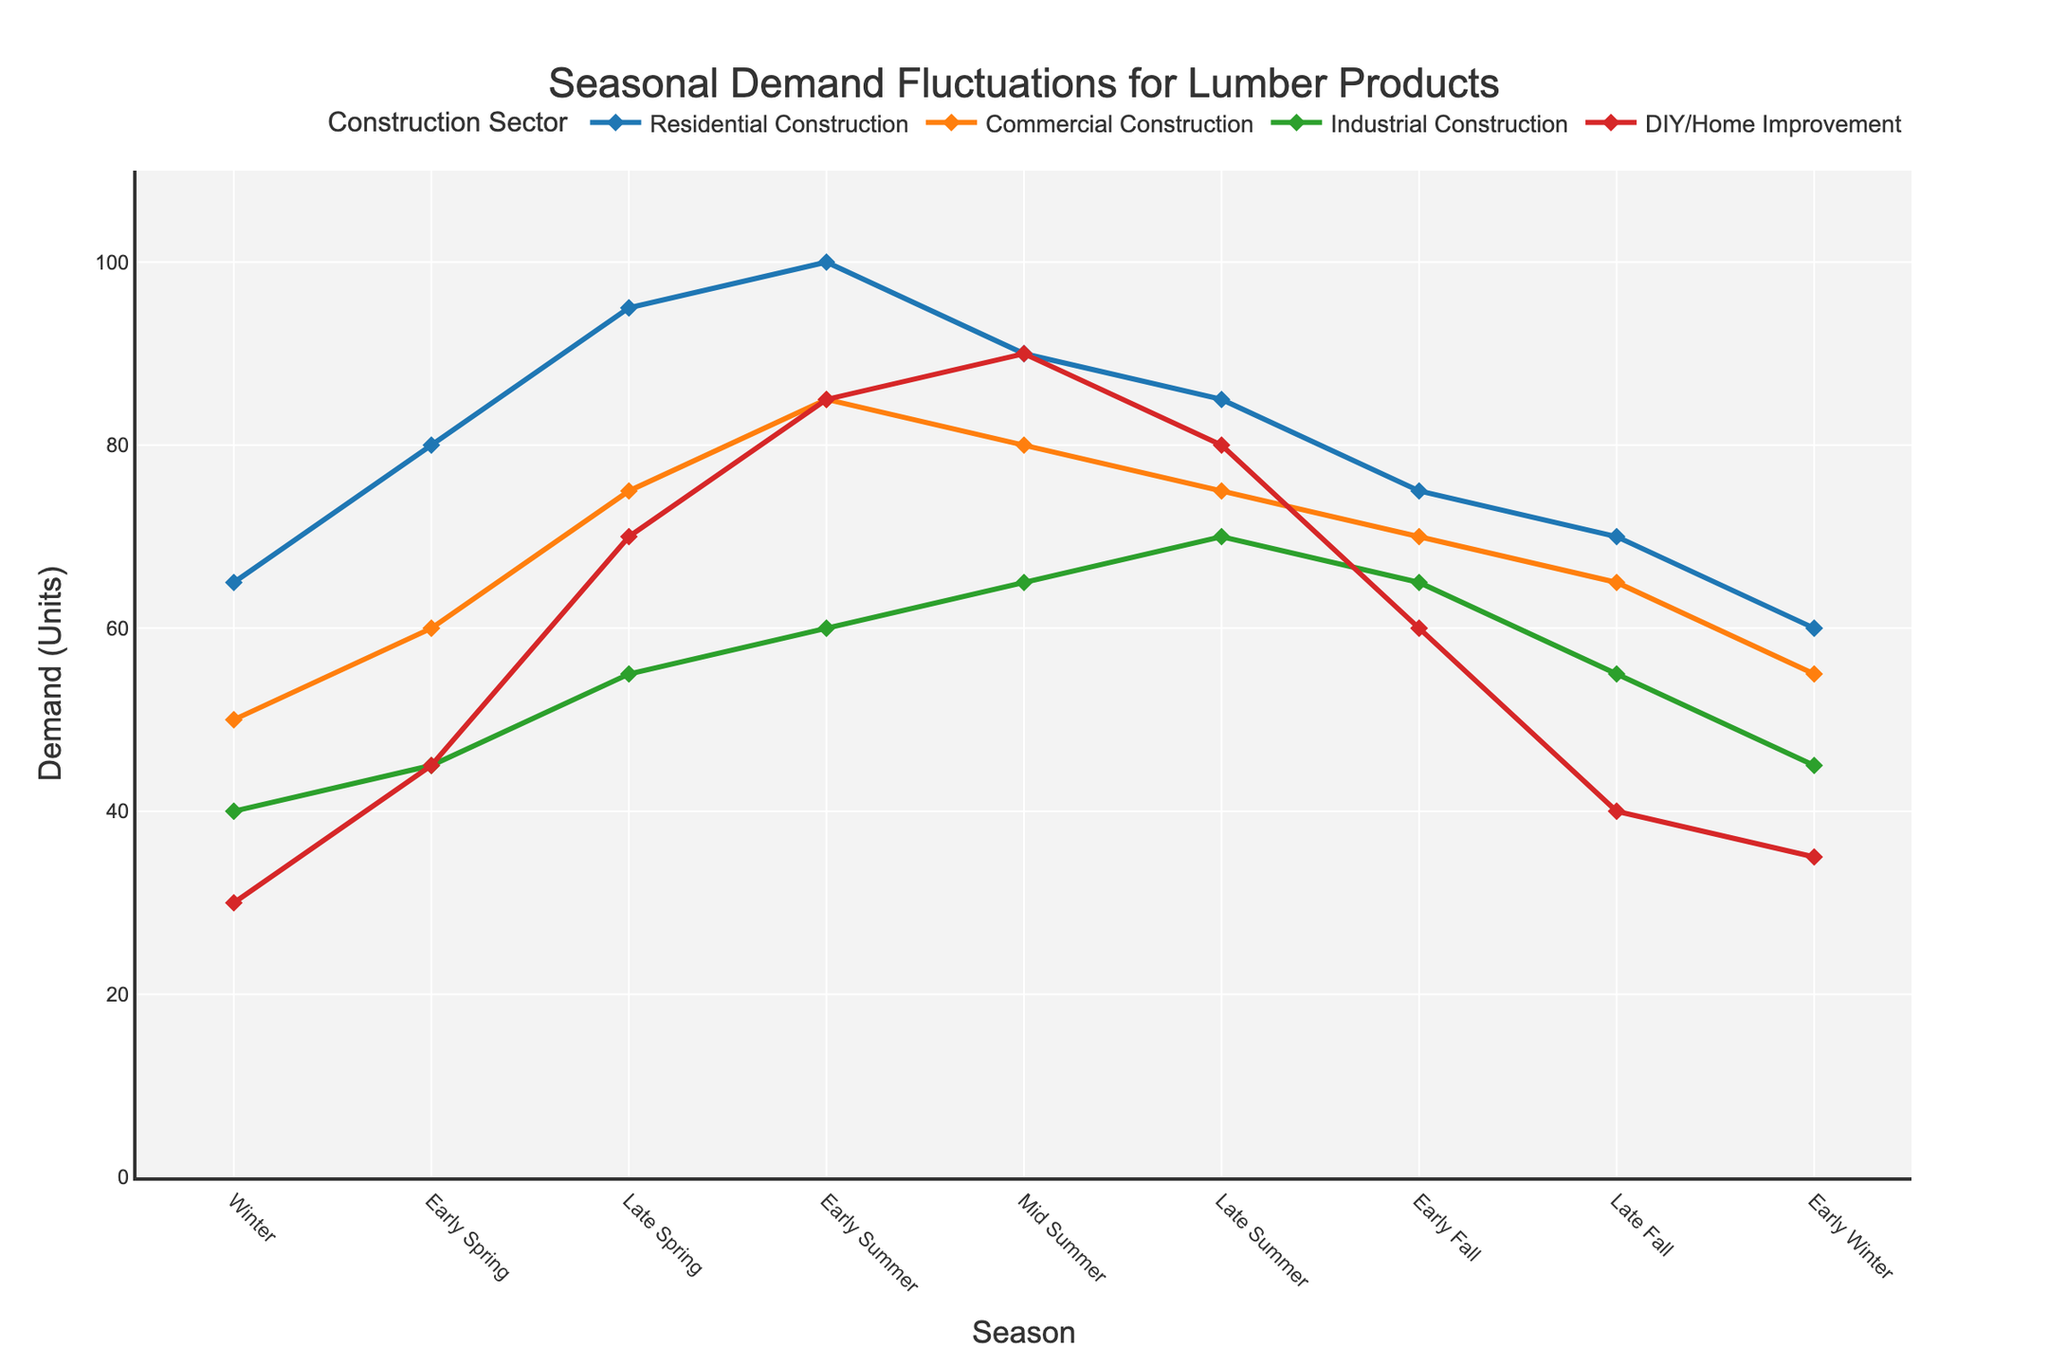Which season has the highest demand in the Residential Construction sector? The line chart shows that the peak demand for Residential Construction is in Early Summer, where the demand reaches 100 units.
Answer: Early Summer How does the demand in the DIY/Home Improvement sector change from Winter to Early Spring? The demand in the DIY/Home Improvement sector increases from 30 units in Winter to 45 units in Early Spring, showing a rise of 15 units.
Answer: It increases by 15 units Compare the demand for Commercial Construction and Industrial Construction in Mid Summer. Which is higher? In Mid Summer, the demand for Commercial Construction is 80 units, while the demand for Industrial Construction is 65 units. Commercial Construction has a higher demand by 15 units.
Answer: Commercial Construction What is the average demand for Residential Construction from Winter to Late Fall? The demands are 65, 80, 95, 100, 90, 85, 75, 70 units. Sum these up: 65 + 80 + 95 + 100 + 90 + 85 + 75 + 70 = 660. There are 8 seasons, so the average demand is 660/8 = 82.5 units.
Answer: 82.5 units During which season does the demand for DIY/Home Improvement reach its peak, and how much is it? According to the figure, the peak demand for DIY/Home Improvement is in Mid Summer when it reaches 90 units.
Answer: Mid Summer, 90 units Which sector shows the most significant increase in demand from Late Spring to Early Summer? From Late Spring to Early Summer, Residential Construction increases from 95 to 100 units (5 units), Commercial Construction from 75 to 85 (10 units), Industrial Construction from 55 to 60 (5 units), and DIY/Home Improvement from 70 to 85 (15 units). DIY/Home Improvement shows the most significant increase with 15 units.
Answer: DIY/Home Improvement What is the difference in demand between Commercial and Industrial Construction in Late Summer? In Late Summer, Commercial Construction has a demand of 75 units, and Industrial Construction has 70 units. The difference is 75 - 70 = 5 units.
Answer: 5 units How does the demand for Residential Construction compare to DIY/Home Improvement throughout the seasons? Generally, Residential Construction demand is higher than DIY/Home Improvement across most seasons. The largest gaps occur in Early Summer and Late Spring, whereas DIY/Home Improvement peaks in Mid Summer and shows more fluctuations throughout the year. Details can be seen from line plots comparing each season's values.
Answer: Residential Construction is generally higher but with more fluctuations What is the total demand in the Industrial Construction sector from Winter to Early Summer? The demands are 40, 45, 55, and 60 units. Total demand = 40 + 45 + 55 + 60 = 200 units.
Answer: 200 units In which season do all sectors experience a drop in demand compared to the previous season? Comparing each sector across consecutive seasons, Early Winter stands out, where Residential drops from 70 to 60, Commercial from 65 to 55, Industrial from 55 to 45, and DIY/Home Improvement from 40 to 35. All sectors experience a decrease.
Answer: Early Winter 